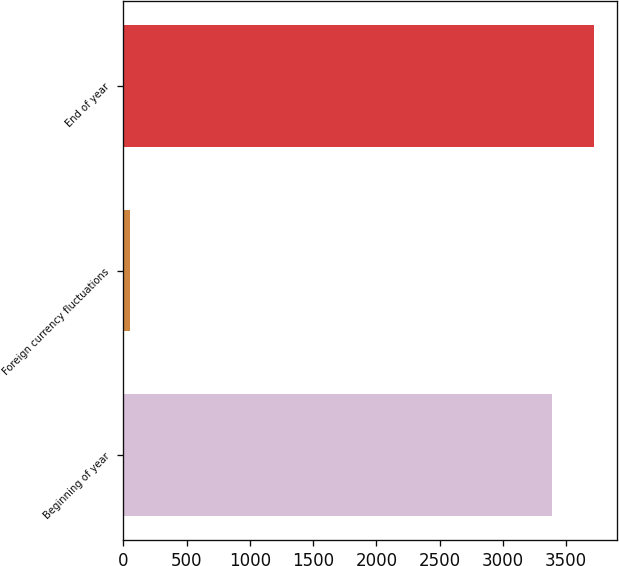Convert chart to OTSL. <chart><loc_0><loc_0><loc_500><loc_500><bar_chart><fcel>Beginning of year<fcel>Foreign currency fluctuations<fcel>End of year<nl><fcel>3385.4<fcel>54.6<fcel>3719.83<nl></chart> 